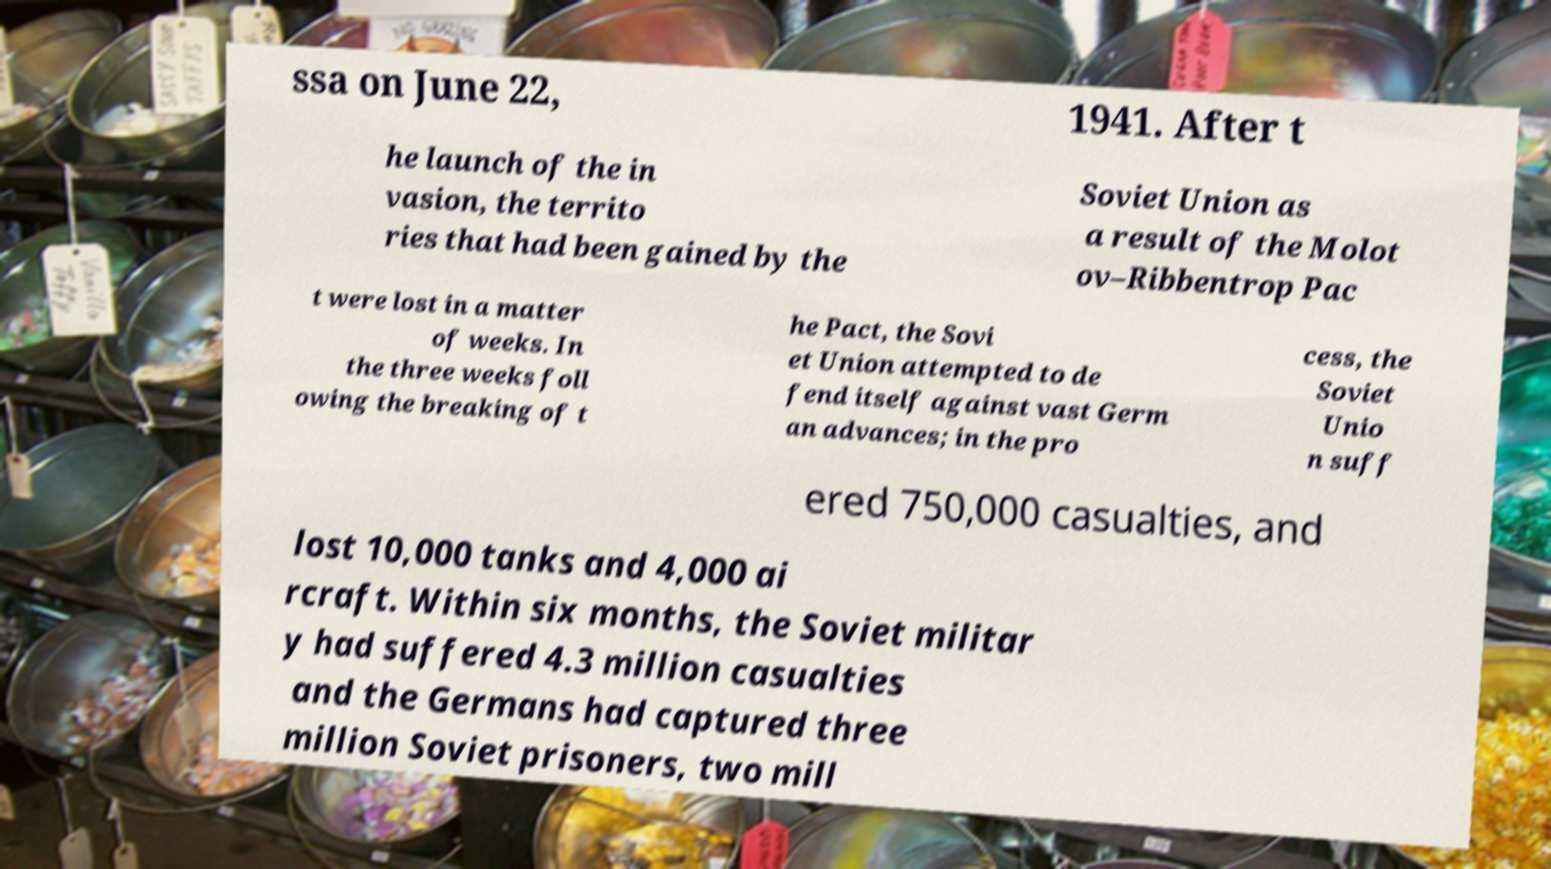Please read and relay the text visible in this image. What does it say? ssa on June 22, 1941. After t he launch of the in vasion, the territo ries that had been gained by the Soviet Union as a result of the Molot ov–Ribbentrop Pac t were lost in a matter of weeks. In the three weeks foll owing the breaking of t he Pact, the Sovi et Union attempted to de fend itself against vast Germ an advances; in the pro cess, the Soviet Unio n suff ered 750,000 casualties, and lost 10,000 tanks and 4,000 ai rcraft. Within six months, the Soviet militar y had suffered 4.3 million casualties and the Germans had captured three million Soviet prisoners, two mill 